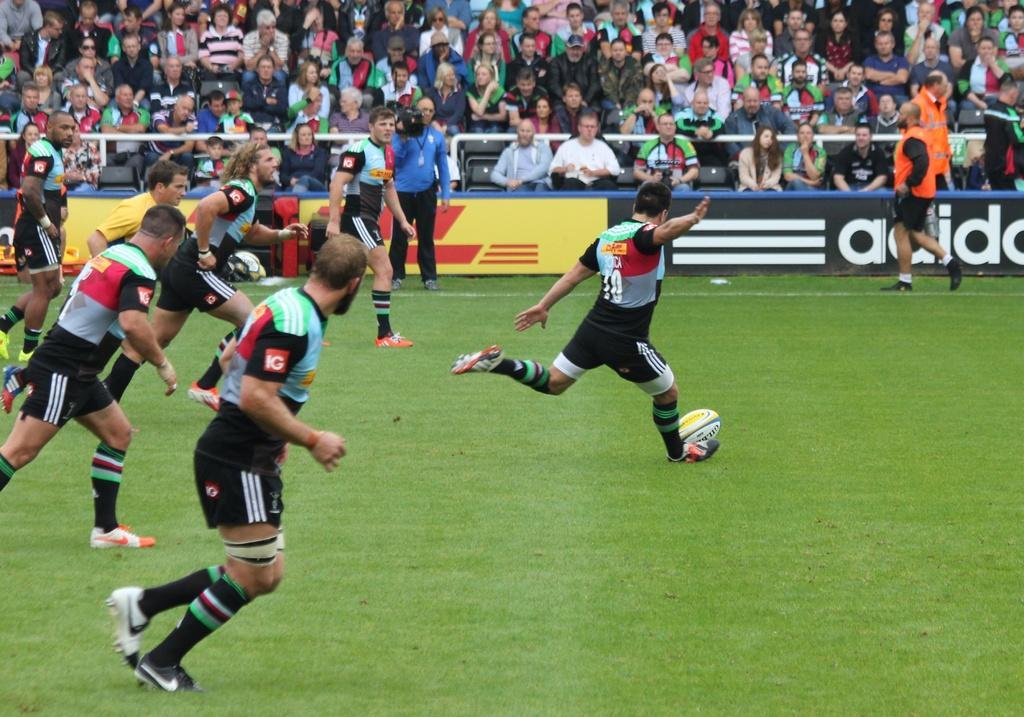In one or two sentences, can you explain what this image depicts? As we can see in the image, there are a lot of people over here. Some people are playing games and the rest of them are watching the game. The man who is standing here is holding camera in his hand. 